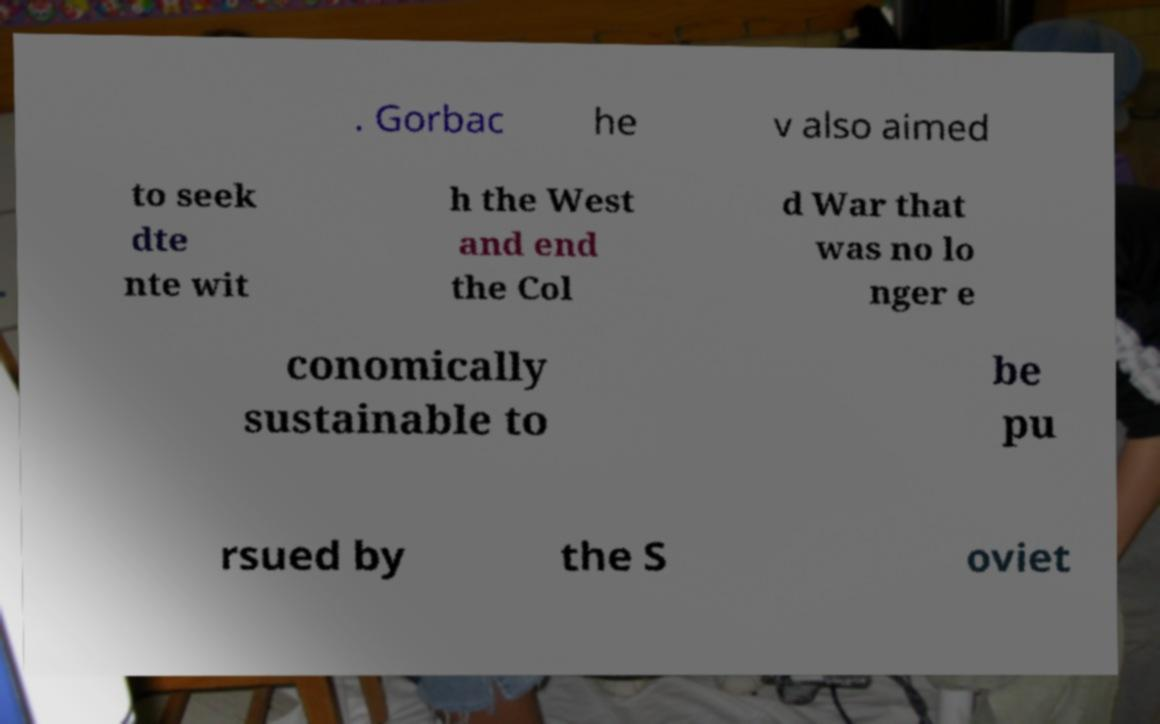Please identify and transcribe the text found in this image. . Gorbac he v also aimed to seek dte nte wit h the West and end the Col d War that was no lo nger e conomically sustainable to be pu rsued by the S oviet 